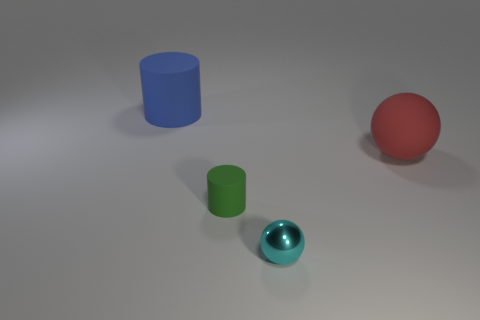How many other objects are there of the same color as the big ball?
Your answer should be compact. 0. What number of metal objects are tiny cubes or large blue things?
Offer a very short reply. 0. There is a large thing left of the cyan sphere; is it the same color as the large matte object that is on the right side of the green matte thing?
Your response must be concise. No. Is there any other thing that is made of the same material as the tiny green object?
Give a very brief answer. Yes. What size is the other object that is the same shape as the cyan object?
Your answer should be very brief. Large. Are there more big matte balls that are in front of the cyan metal thing than big red rubber objects?
Your answer should be very brief. No. Does the big object that is to the left of the small cyan shiny thing have the same material as the green object?
Provide a succinct answer. Yes. What is the size of the blue object on the left side of the cylinder to the right of the matte thing left of the tiny green thing?
Provide a succinct answer. Large. What is the size of the green object that is made of the same material as the big red sphere?
Ensure brevity in your answer.  Small. There is a object that is both on the left side of the cyan shiny object and in front of the big red sphere; what color is it?
Give a very brief answer. Green. 